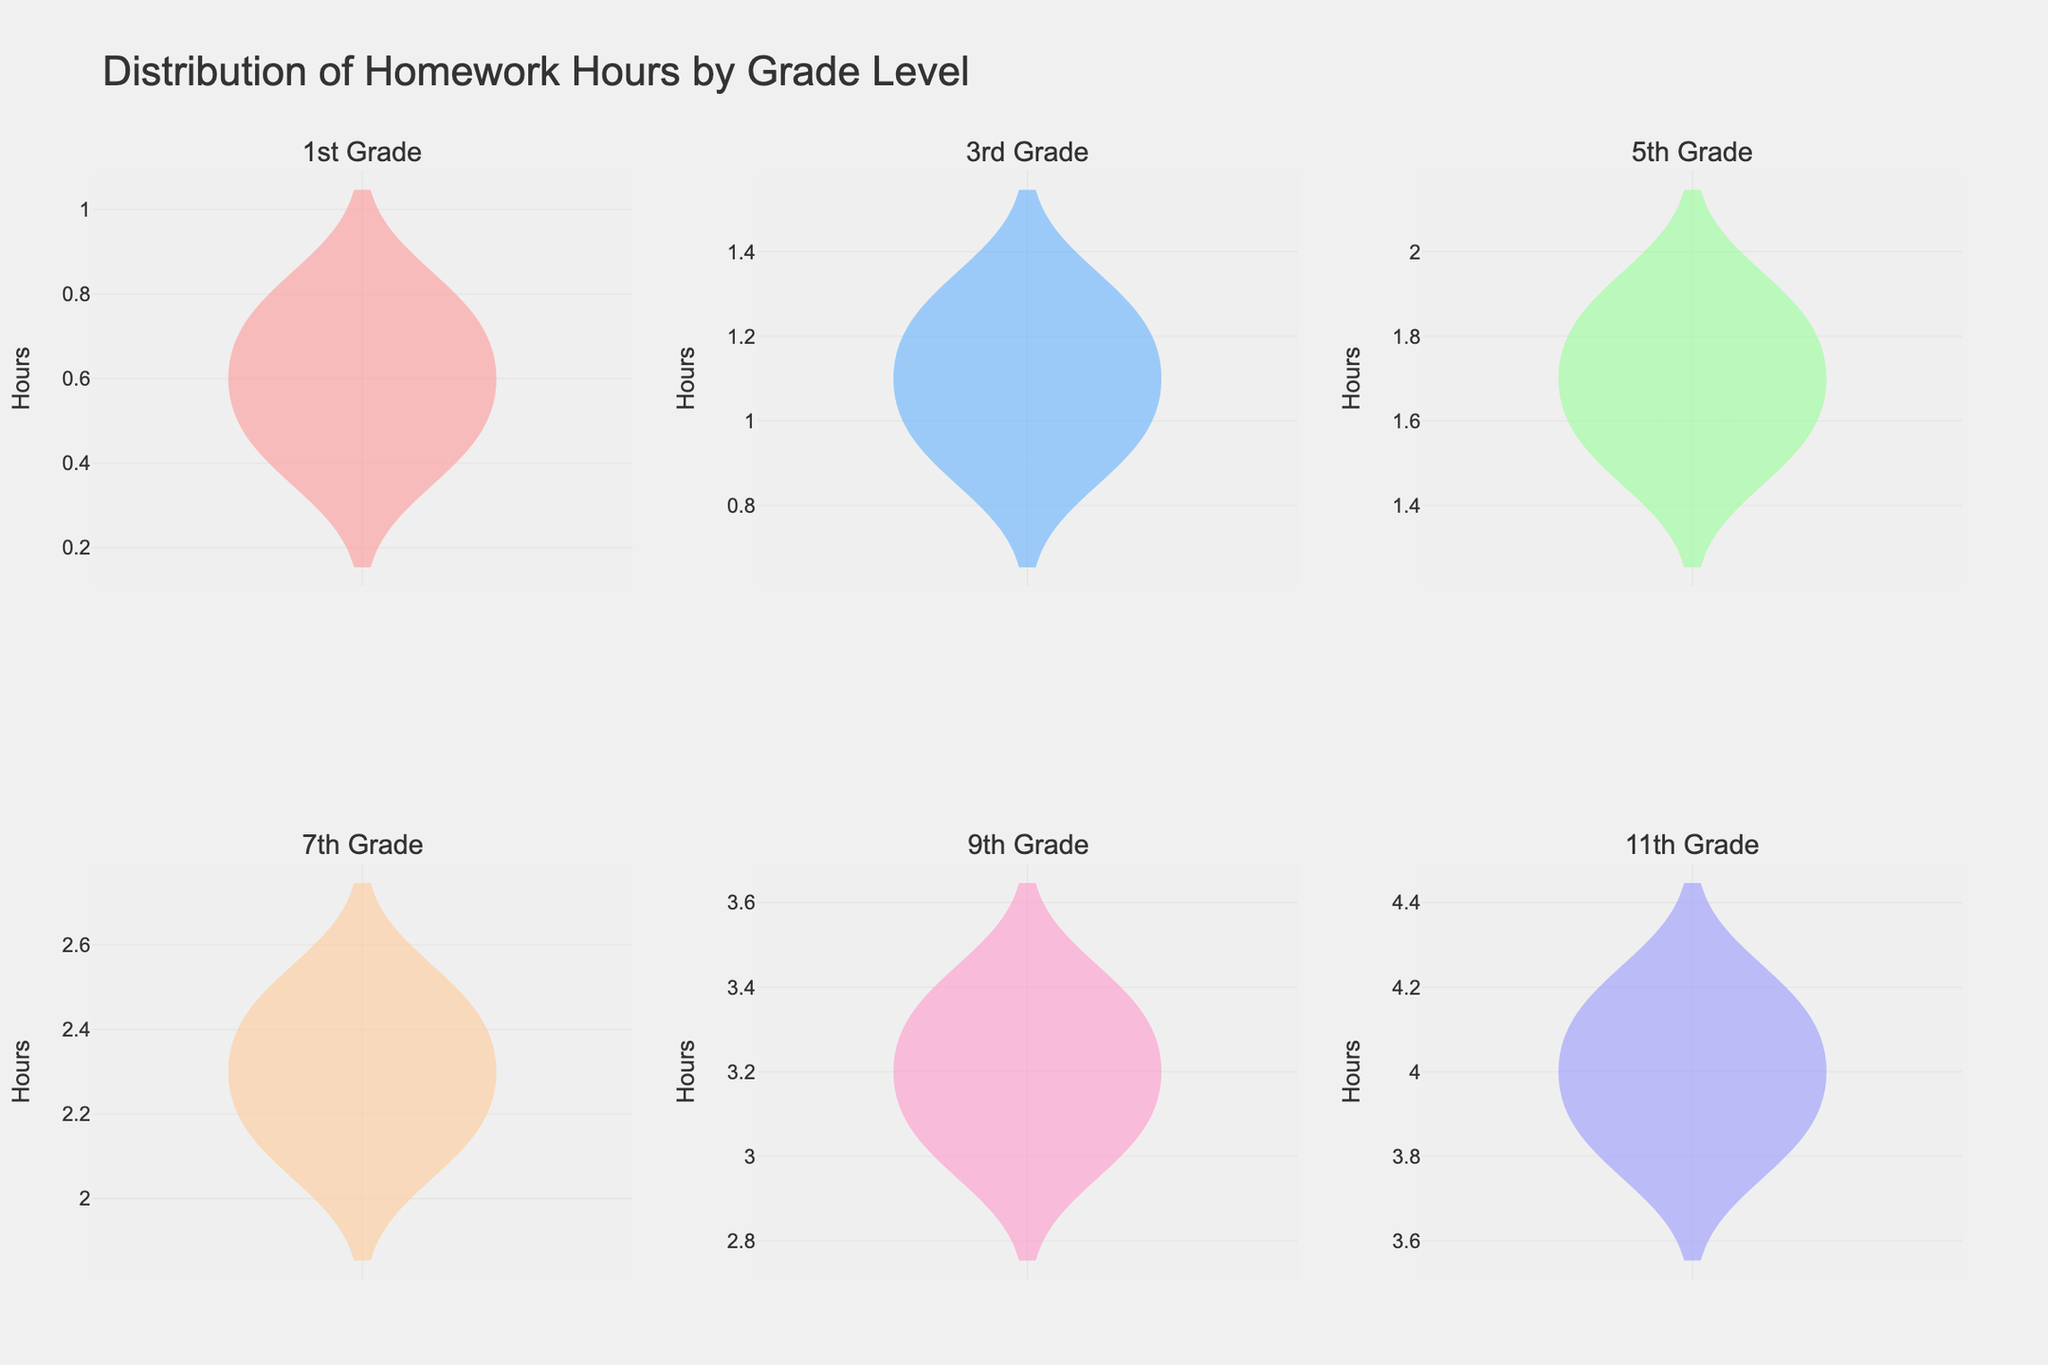What is the title of the figure? The title of the figure is displayed at the top center.
Answer: Distribution of Homework Hours by Grade Level What is the range of hours spent on homework for 1st Grade students? The range can be determined by looking at the min and max points of the violin plot for 1st Grade.
Answer: 0.4 to 0.8 How many grade levels are shown in the figure? Each subplot represents a different grade level, and there are a total of 6 subplots.
Answer: 6 Which grade level spends the most time on homework on average? By comparing the meanlines (horizontal lines in each subplot) across all the plots, the grade with the highest meanline is identified.
Answer: 11th Grade What are the colors used in the plots? The colors of the violin plots can be visually identified.
Answer: Red, Blue, Green, Orange, Pink, Purple Which grade level has the smallest spread of hours spent on homework? The grade level with the violin plot that has the shortest range indicates the smallest spread.
Answer: 1st Grade Compare the median hours spent on homework between 5th Grade and 7th Grade. Which is higher? The median can be inferred from the thickest part of each violin plot. Comparing these between the two grades will show which one is higher.
Answer: 7th Grade How does the distribution of hours spent on homework change from 1st Grade to 11th Grade? By observing the violin plots from 1st Grade to 11th Grade, the general trend of how the range and median of hours spent changes can be noted.
Answer: Increases consistently What is the y-axis labeled as in all the subplots? The y-axis label is noted beside the axis in each subplot.
Answer: Hours What is the mean number of hours spent on homework by 9th Grade students? This can be observed by looking at the meanline within the 9th Grade subplot.
Answer: 3.2 